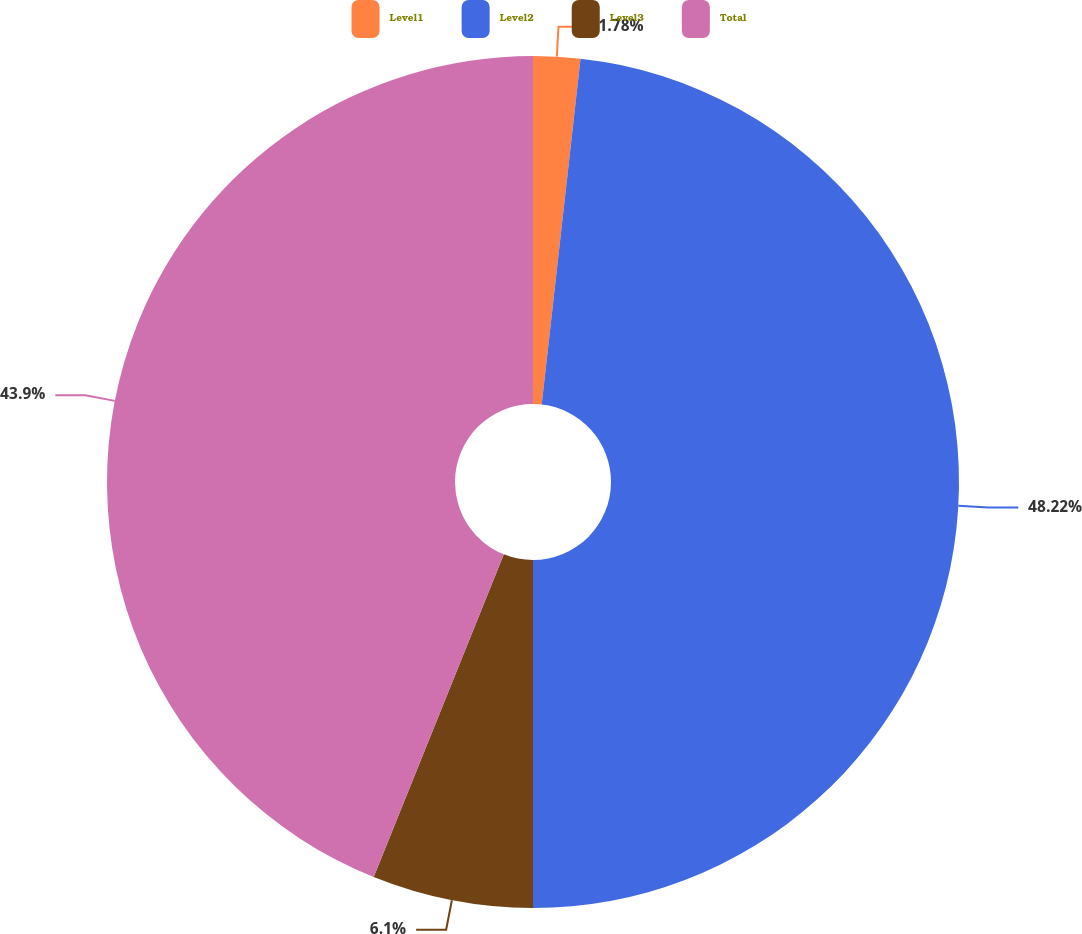<chart> <loc_0><loc_0><loc_500><loc_500><pie_chart><fcel>Level1<fcel>Level2<fcel>Level3<fcel>Total<nl><fcel>1.78%<fcel>48.22%<fcel>6.1%<fcel>43.9%<nl></chart> 